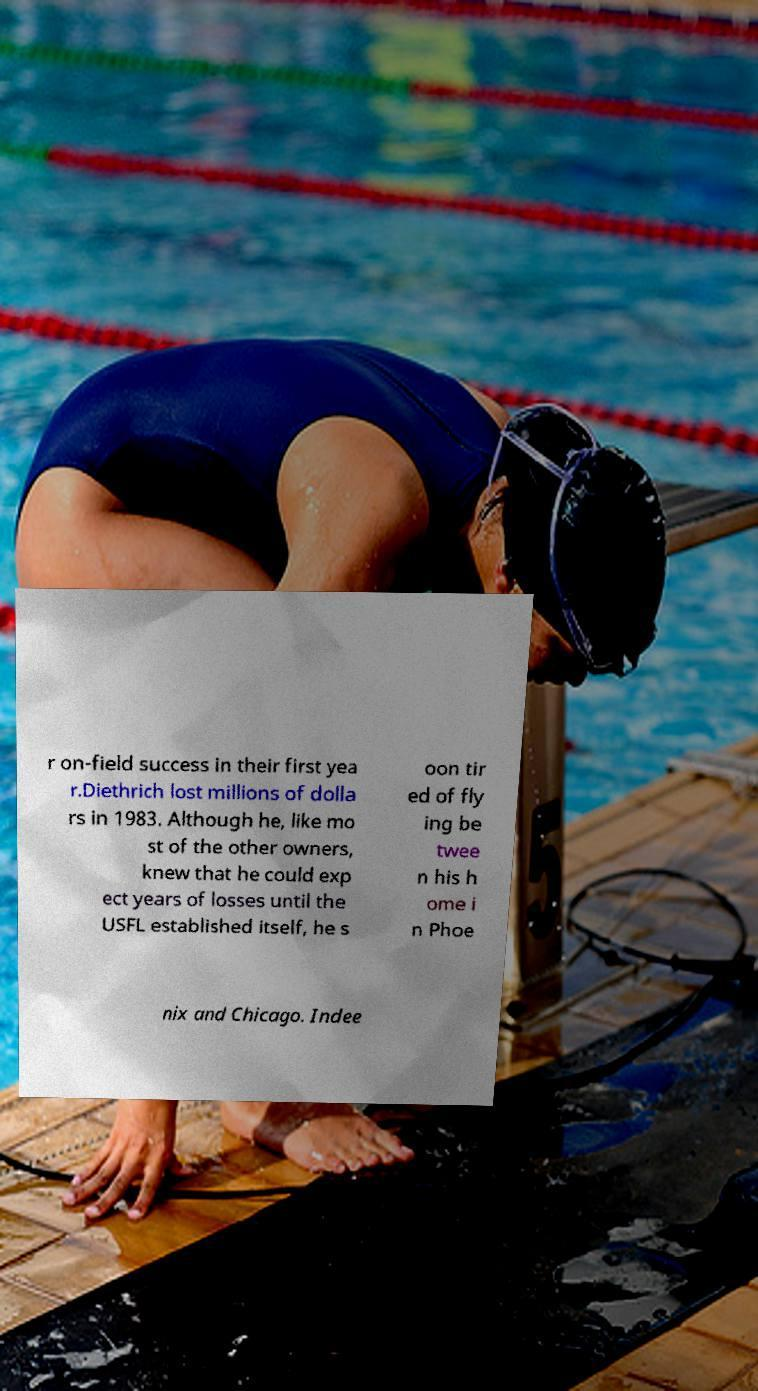Can you accurately transcribe the text from the provided image for me? r on-field success in their first yea r.Diethrich lost millions of dolla rs in 1983. Although he, like mo st of the other owners, knew that he could exp ect years of losses until the USFL established itself, he s oon tir ed of fly ing be twee n his h ome i n Phoe nix and Chicago. Indee 